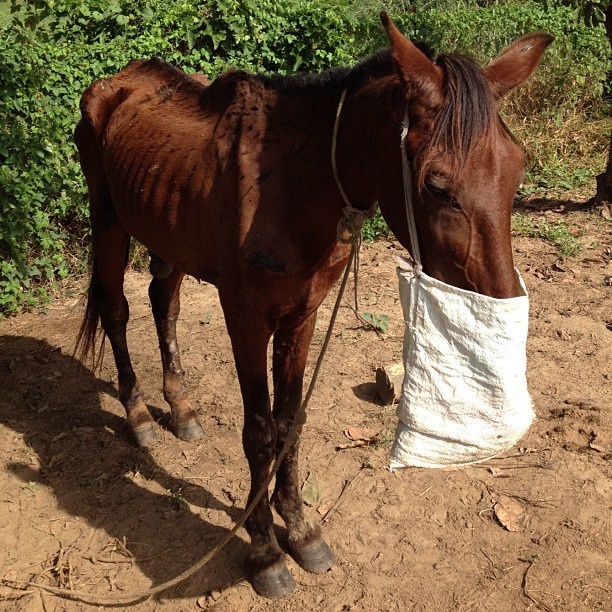Describe the objects in this image and their specific colors. I can see a horse in darkgreen, black, maroon, and gray tones in this image. 